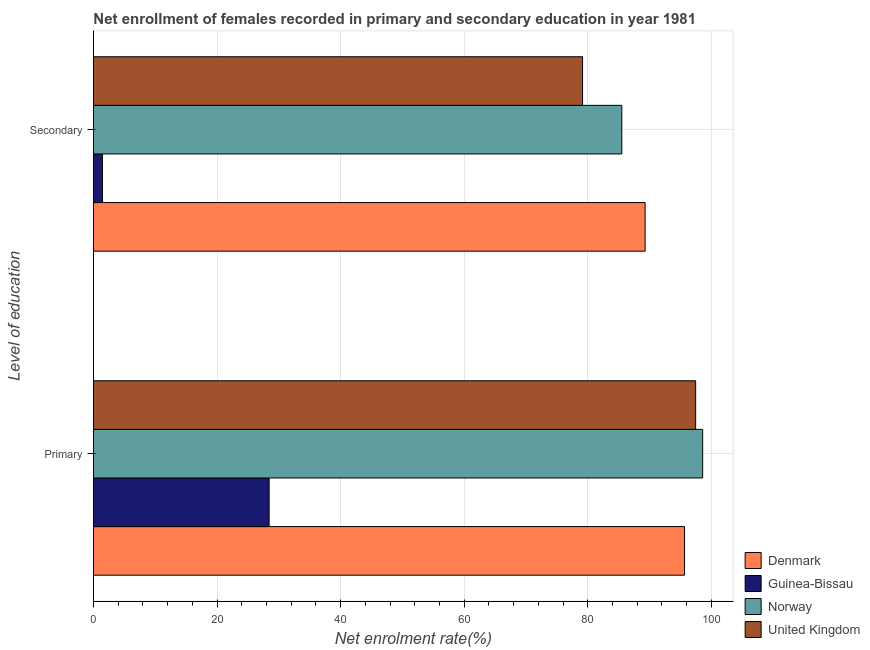How many different coloured bars are there?
Provide a succinct answer. 4. How many groups of bars are there?
Ensure brevity in your answer.  2. Are the number of bars on each tick of the Y-axis equal?
Your response must be concise. Yes. How many bars are there on the 1st tick from the top?
Provide a succinct answer. 4. What is the label of the 2nd group of bars from the top?
Offer a very short reply. Primary. What is the enrollment rate in secondary education in United Kingdom?
Give a very brief answer. 79.15. Across all countries, what is the maximum enrollment rate in primary education?
Ensure brevity in your answer.  98.59. Across all countries, what is the minimum enrollment rate in secondary education?
Offer a very short reply. 1.45. In which country was the enrollment rate in primary education maximum?
Offer a terse response. Norway. In which country was the enrollment rate in primary education minimum?
Make the answer very short. Guinea-Bissau. What is the total enrollment rate in primary education in the graph?
Make the answer very short. 320.14. What is the difference between the enrollment rate in primary education in Guinea-Bissau and that in Norway?
Provide a succinct answer. -70.16. What is the difference between the enrollment rate in secondary education in Norway and the enrollment rate in primary education in United Kingdom?
Your answer should be very brief. -11.95. What is the average enrollment rate in secondary education per country?
Your response must be concise. 63.85. What is the difference between the enrollment rate in secondary education and enrollment rate in primary education in Guinea-Bissau?
Provide a succinct answer. -26.98. In how many countries, is the enrollment rate in secondary education greater than 64 %?
Your answer should be compact. 3. What is the ratio of the enrollment rate in secondary education in Guinea-Bissau to that in Norway?
Ensure brevity in your answer.  0.02. Is the enrollment rate in primary education in Denmark less than that in Guinea-Bissau?
Offer a terse response. No. In how many countries, is the enrollment rate in primary education greater than the average enrollment rate in primary education taken over all countries?
Keep it short and to the point. 3. What does the 3rd bar from the top in Primary represents?
Make the answer very short. Guinea-Bissau. Does the graph contain any zero values?
Ensure brevity in your answer.  No. Does the graph contain grids?
Ensure brevity in your answer.  Yes. Where does the legend appear in the graph?
Make the answer very short. Bottom right. How are the legend labels stacked?
Provide a short and direct response. Vertical. What is the title of the graph?
Provide a succinct answer. Net enrollment of females recorded in primary and secondary education in year 1981. Does "Indonesia" appear as one of the legend labels in the graph?
Your answer should be compact. No. What is the label or title of the X-axis?
Give a very brief answer. Net enrolment rate(%). What is the label or title of the Y-axis?
Your answer should be compact. Level of education. What is the Net enrolment rate(%) of Denmark in Primary?
Give a very brief answer. 95.66. What is the Net enrolment rate(%) of Guinea-Bissau in Primary?
Your answer should be compact. 28.43. What is the Net enrolment rate(%) of Norway in Primary?
Provide a short and direct response. 98.59. What is the Net enrolment rate(%) of United Kingdom in Primary?
Provide a short and direct response. 97.46. What is the Net enrolment rate(%) of Denmark in Secondary?
Your answer should be very brief. 89.28. What is the Net enrolment rate(%) in Guinea-Bissau in Secondary?
Your answer should be very brief. 1.45. What is the Net enrolment rate(%) in Norway in Secondary?
Keep it short and to the point. 85.5. What is the Net enrolment rate(%) of United Kingdom in Secondary?
Keep it short and to the point. 79.15. Across all Level of education, what is the maximum Net enrolment rate(%) of Denmark?
Give a very brief answer. 95.66. Across all Level of education, what is the maximum Net enrolment rate(%) in Guinea-Bissau?
Ensure brevity in your answer.  28.43. Across all Level of education, what is the maximum Net enrolment rate(%) of Norway?
Offer a very short reply. 98.59. Across all Level of education, what is the maximum Net enrolment rate(%) in United Kingdom?
Your answer should be compact. 97.46. Across all Level of education, what is the minimum Net enrolment rate(%) in Denmark?
Keep it short and to the point. 89.28. Across all Level of education, what is the minimum Net enrolment rate(%) of Guinea-Bissau?
Your answer should be very brief. 1.45. Across all Level of education, what is the minimum Net enrolment rate(%) of Norway?
Ensure brevity in your answer.  85.5. Across all Level of education, what is the minimum Net enrolment rate(%) in United Kingdom?
Offer a very short reply. 79.15. What is the total Net enrolment rate(%) in Denmark in the graph?
Make the answer very short. 184.94. What is the total Net enrolment rate(%) of Guinea-Bissau in the graph?
Offer a very short reply. 29.88. What is the total Net enrolment rate(%) of Norway in the graph?
Your answer should be very brief. 184.1. What is the total Net enrolment rate(%) of United Kingdom in the graph?
Your response must be concise. 176.61. What is the difference between the Net enrolment rate(%) in Denmark in Primary and that in Secondary?
Provide a succinct answer. 6.38. What is the difference between the Net enrolment rate(%) in Guinea-Bissau in Primary and that in Secondary?
Your response must be concise. 26.98. What is the difference between the Net enrolment rate(%) of Norway in Primary and that in Secondary?
Your answer should be compact. 13.09. What is the difference between the Net enrolment rate(%) of United Kingdom in Primary and that in Secondary?
Keep it short and to the point. 18.3. What is the difference between the Net enrolment rate(%) in Denmark in Primary and the Net enrolment rate(%) in Guinea-Bissau in Secondary?
Keep it short and to the point. 94.21. What is the difference between the Net enrolment rate(%) in Denmark in Primary and the Net enrolment rate(%) in Norway in Secondary?
Your answer should be very brief. 10.15. What is the difference between the Net enrolment rate(%) of Denmark in Primary and the Net enrolment rate(%) of United Kingdom in Secondary?
Your answer should be very brief. 16.5. What is the difference between the Net enrolment rate(%) in Guinea-Bissau in Primary and the Net enrolment rate(%) in Norway in Secondary?
Offer a very short reply. -57.07. What is the difference between the Net enrolment rate(%) in Guinea-Bissau in Primary and the Net enrolment rate(%) in United Kingdom in Secondary?
Provide a short and direct response. -50.72. What is the difference between the Net enrolment rate(%) in Norway in Primary and the Net enrolment rate(%) in United Kingdom in Secondary?
Offer a terse response. 19.44. What is the average Net enrolment rate(%) of Denmark per Level of education?
Provide a short and direct response. 92.47. What is the average Net enrolment rate(%) of Guinea-Bissau per Level of education?
Provide a succinct answer. 14.94. What is the average Net enrolment rate(%) in Norway per Level of education?
Make the answer very short. 92.05. What is the average Net enrolment rate(%) in United Kingdom per Level of education?
Make the answer very short. 88.31. What is the difference between the Net enrolment rate(%) in Denmark and Net enrolment rate(%) in Guinea-Bissau in Primary?
Offer a terse response. 67.23. What is the difference between the Net enrolment rate(%) in Denmark and Net enrolment rate(%) in Norway in Primary?
Make the answer very short. -2.94. What is the difference between the Net enrolment rate(%) in Denmark and Net enrolment rate(%) in United Kingdom in Primary?
Provide a short and direct response. -1.8. What is the difference between the Net enrolment rate(%) of Guinea-Bissau and Net enrolment rate(%) of Norway in Primary?
Your answer should be very brief. -70.16. What is the difference between the Net enrolment rate(%) of Guinea-Bissau and Net enrolment rate(%) of United Kingdom in Primary?
Provide a short and direct response. -69.03. What is the difference between the Net enrolment rate(%) in Norway and Net enrolment rate(%) in United Kingdom in Primary?
Your answer should be compact. 1.14. What is the difference between the Net enrolment rate(%) of Denmark and Net enrolment rate(%) of Guinea-Bissau in Secondary?
Offer a terse response. 87.83. What is the difference between the Net enrolment rate(%) in Denmark and Net enrolment rate(%) in Norway in Secondary?
Provide a succinct answer. 3.77. What is the difference between the Net enrolment rate(%) in Denmark and Net enrolment rate(%) in United Kingdom in Secondary?
Offer a terse response. 10.12. What is the difference between the Net enrolment rate(%) in Guinea-Bissau and Net enrolment rate(%) in Norway in Secondary?
Your answer should be very brief. -84.05. What is the difference between the Net enrolment rate(%) in Guinea-Bissau and Net enrolment rate(%) in United Kingdom in Secondary?
Make the answer very short. -77.7. What is the difference between the Net enrolment rate(%) of Norway and Net enrolment rate(%) of United Kingdom in Secondary?
Ensure brevity in your answer.  6.35. What is the ratio of the Net enrolment rate(%) in Denmark in Primary to that in Secondary?
Make the answer very short. 1.07. What is the ratio of the Net enrolment rate(%) in Guinea-Bissau in Primary to that in Secondary?
Your response must be concise. 19.58. What is the ratio of the Net enrolment rate(%) of Norway in Primary to that in Secondary?
Your response must be concise. 1.15. What is the ratio of the Net enrolment rate(%) in United Kingdom in Primary to that in Secondary?
Your answer should be very brief. 1.23. What is the difference between the highest and the second highest Net enrolment rate(%) in Denmark?
Ensure brevity in your answer.  6.38. What is the difference between the highest and the second highest Net enrolment rate(%) in Guinea-Bissau?
Your response must be concise. 26.98. What is the difference between the highest and the second highest Net enrolment rate(%) of Norway?
Offer a very short reply. 13.09. What is the difference between the highest and the second highest Net enrolment rate(%) in United Kingdom?
Provide a succinct answer. 18.3. What is the difference between the highest and the lowest Net enrolment rate(%) of Denmark?
Keep it short and to the point. 6.38. What is the difference between the highest and the lowest Net enrolment rate(%) in Guinea-Bissau?
Provide a succinct answer. 26.98. What is the difference between the highest and the lowest Net enrolment rate(%) in Norway?
Provide a short and direct response. 13.09. What is the difference between the highest and the lowest Net enrolment rate(%) in United Kingdom?
Your answer should be compact. 18.3. 